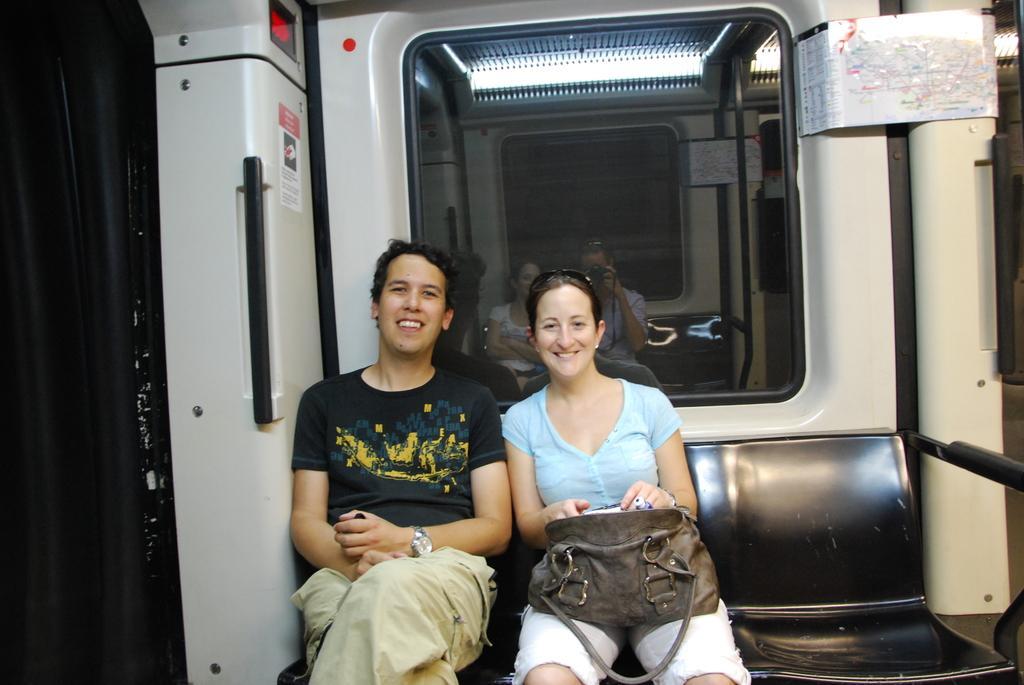In one or two sentences, can you explain what this image depicts? In this image I can see a m an and a woman are sitting on a bench. Here I can see smile on their faces and also I can see she is holding a bag. 